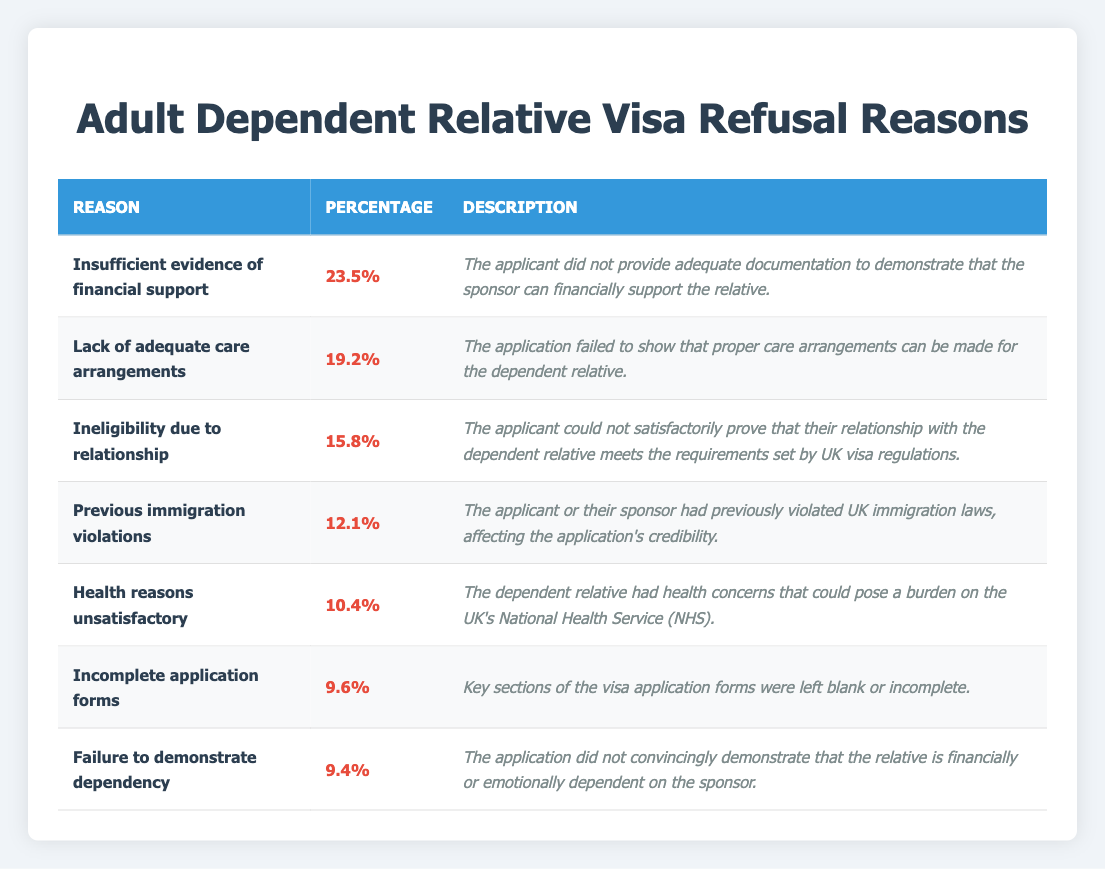What is the reason for the highest percentage of refusal? The table shows that "Insufficient evidence of financial support" has the highest percentage of refusal at 23.5%.
Answer: Insufficient evidence of financial support What percentage of refusals is due to health reasons? According to the table, "Health reasons unsatisfactory" accounts for 10.4% of refusals.
Answer: 10.4% Is the "Failure to demonstrate dependency" reason more than or equal to 10%? The percentage for "Failure to demonstrate dependency" is 9.4%, which is less than 10%.
Answer: No What is the combined percentage of refusals due to "Incomplete application forms" and "Health reasons unsatisfactory"? To find the combined percentage, add the two percentages: 9.6% (Incomplete application forms) + 10.4% (Health reasons unsatisfactory) = 20%.
Answer: 20% Is there a higher percentage of refusals due to "Lack of adequate care arrangements" compared to "Ineligibility due to relationship"? The refusal percentage for "Lack of adequate care arrangements" is 19.2%, while "Ineligibility due to relationship" is 15.8%. Since 19.2% is greater than 15.8%, this statement is true.
Answer: Yes What is the average percentage of refusals for the reasons listed in the table? There are seven reasons listed. The total percentage is 100% (23.5 + 19.2 + 15.8 + 12.1 + 10.4 + 9.6 + 9.4 = 100), so the average is 100% divided by 7 = approximately 14.29%.
Answer: 14.29% How many reasons for refusal have percentages below 15%? The reasons with percentages below 15% are "Previous immigration violations" (12.1%), "Health reasons unsatisfactory" (10.4%), "Incomplete application forms" (9.6%), and "Failure to demonstrate dependency" (9.4%). This totals four reasons.
Answer: 4 Which reason has the second highest percentage of refusal? The second highest percentage of refusal is for "Lack of adequate care arrangements" at 19.2%.
Answer: Lack of adequate care arrangements If you combine the percentages for "Previous immigration violations" and "Ineligibility due to relationship", what is the total? Adding both percentages gives 12.1% (Previous immigration violations) + 15.8% (Ineligibility due to relationship) = 27.9%.
Answer: 27.9% 